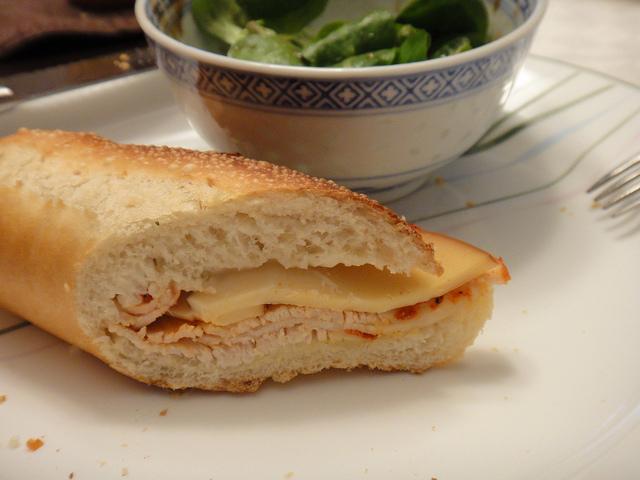What is in the cup?
Answer briefly. Salad. Is this for breakfast?
Short answer required. No. Is this a ham and cheese sandwich?
Keep it brief. No. What type of sandwich is this?
Give a very brief answer. Turkey and cheese. What is in the bowl?
Keep it brief. Salad. Where is the bowl?
Keep it brief. Behind sandwich. Does the sandwich have any vegetables?
Be succinct. No. What is the sandwich?
Quick response, please. Turkey and cheese. Are the sandwiches ready to eat?
Quick response, please. Yes. Would this sandwich be warm?
Short answer required. No. Is this healthy?
Be succinct. Yes. What type of fruit is by the sandwich?
Be succinct. None. Is there a spoon?
Quick response, please. No. Is there egg in the sandwich?
Short answer required. No. What is the vegetable called?
Write a very short answer. Spinach. What is in the plastic bowl?
Keep it brief. Salad. What kind of meat is on the sandwich?
Quick response, please. Turkey. What type of cuisine is this?
Write a very short answer. American. 